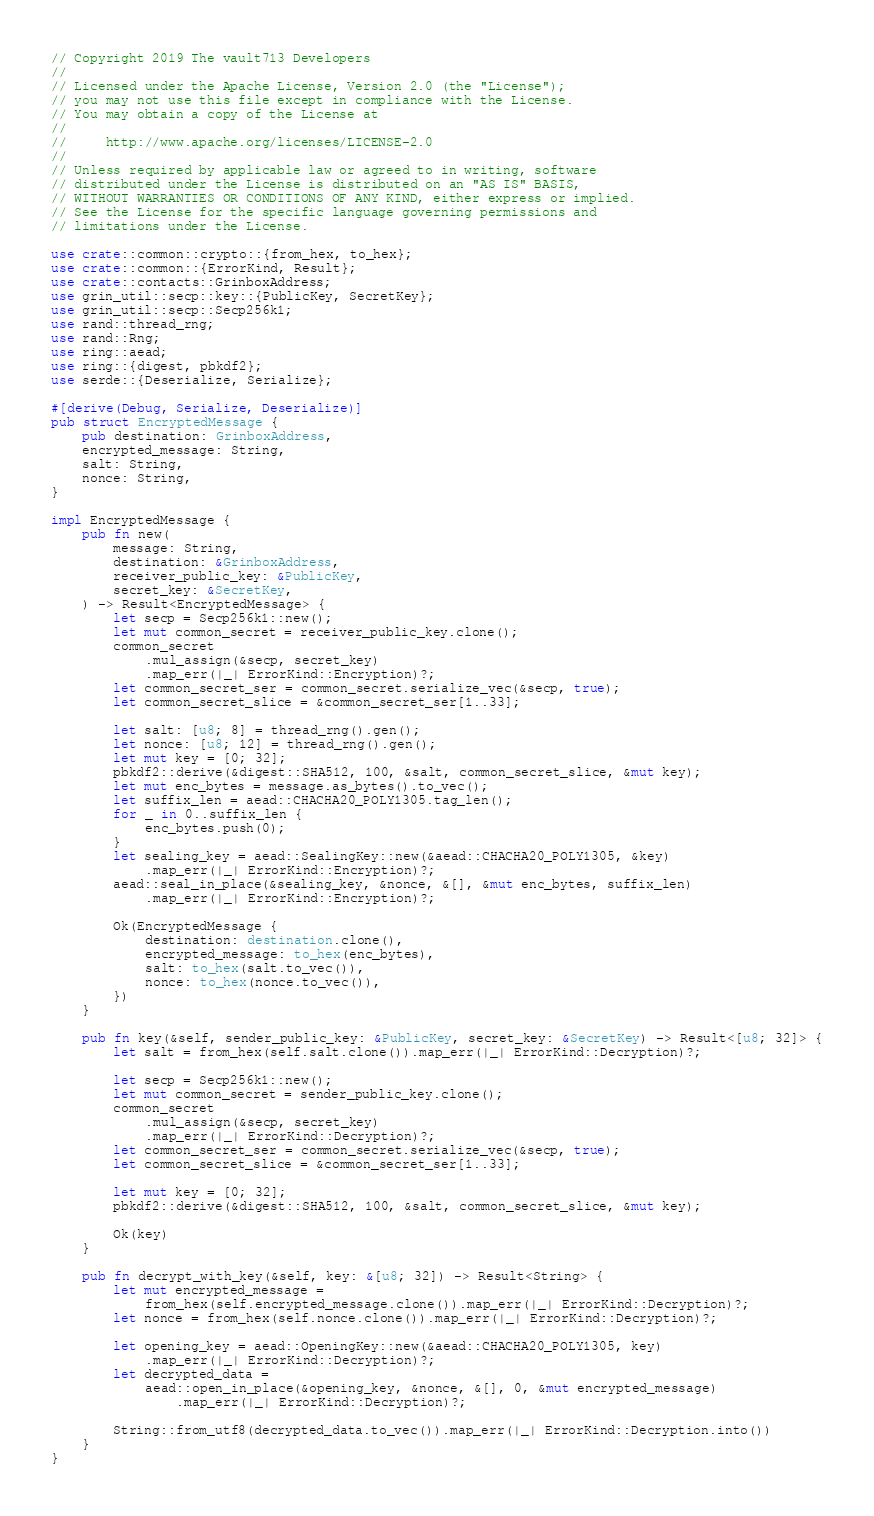<code> <loc_0><loc_0><loc_500><loc_500><_Rust_>// Copyright 2019 The vault713 Developers
//
// Licensed under the Apache License, Version 2.0 (the "License");
// you may not use this file except in compliance with the License.
// You may obtain a copy of the License at
//
//     http://www.apache.org/licenses/LICENSE-2.0
//
// Unless required by applicable law or agreed to in writing, software
// distributed under the License is distributed on an "AS IS" BASIS,
// WITHOUT WARRANTIES OR CONDITIONS OF ANY KIND, either express or implied.
// See the License for the specific language governing permissions and
// limitations under the License.

use crate::common::crypto::{from_hex, to_hex};
use crate::common::{ErrorKind, Result};
use crate::contacts::GrinboxAddress;
use grin_util::secp::key::{PublicKey, SecretKey};
use grin_util::secp::Secp256k1;
use rand::thread_rng;
use rand::Rng;
use ring::aead;
use ring::{digest, pbkdf2};
use serde::{Deserialize, Serialize};

#[derive(Debug, Serialize, Deserialize)]
pub struct EncryptedMessage {
	pub destination: GrinboxAddress,
	encrypted_message: String,
	salt: String,
	nonce: String,
}

impl EncryptedMessage {
	pub fn new(
		message: String,
		destination: &GrinboxAddress,
		receiver_public_key: &PublicKey,
		secret_key: &SecretKey,
	) -> Result<EncryptedMessage> {
		let secp = Secp256k1::new();
		let mut common_secret = receiver_public_key.clone();
		common_secret
			.mul_assign(&secp, secret_key)
			.map_err(|_| ErrorKind::Encryption)?;
		let common_secret_ser = common_secret.serialize_vec(&secp, true);
		let common_secret_slice = &common_secret_ser[1..33];

		let salt: [u8; 8] = thread_rng().gen();
		let nonce: [u8; 12] = thread_rng().gen();
		let mut key = [0; 32];
		pbkdf2::derive(&digest::SHA512, 100, &salt, common_secret_slice, &mut key);
		let mut enc_bytes = message.as_bytes().to_vec();
		let suffix_len = aead::CHACHA20_POLY1305.tag_len();
		for _ in 0..suffix_len {
			enc_bytes.push(0);
		}
		let sealing_key = aead::SealingKey::new(&aead::CHACHA20_POLY1305, &key)
			.map_err(|_| ErrorKind::Encryption)?;
		aead::seal_in_place(&sealing_key, &nonce, &[], &mut enc_bytes, suffix_len)
			.map_err(|_| ErrorKind::Encryption)?;

		Ok(EncryptedMessage {
			destination: destination.clone(),
			encrypted_message: to_hex(enc_bytes),
			salt: to_hex(salt.to_vec()),
			nonce: to_hex(nonce.to_vec()),
		})
	}

	pub fn key(&self, sender_public_key: &PublicKey, secret_key: &SecretKey) -> Result<[u8; 32]> {
		let salt = from_hex(self.salt.clone()).map_err(|_| ErrorKind::Decryption)?;

		let secp = Secp256k1::new();
		let mut common_secret = sender_public_key.clone();
		common_secret
			.mul_assign(&secp, secret_key)
			.map_err(|_| ErrorKind::Decryption)?;
		let common_secret_ser = common_secret.serialize_vec(&secp, true);
		let common_secret_slice = &common_secret_ser[1..33];

		let mut key = [0; 32];
		pbkdf2::derive(&digest::SHA512, 100, &salt, common_secret_slice, &mut key);

		Ok(key)
	}

	pub fn decrypt_with_key(&self, key: &[u8; 32]) -> Result<String> {
		let mut encrypted_message =
			from_hex(self.encrypted_message.clone()).map_err(|_| ErrorKind::Decryption)?;
		let nonce = from_hex(self.nonce.clone()).map_err(|_| ErrorKind::Decryption)?;

		let opening_key = aead::OpeningKey::new(&aead::CHACHA20_POLY1305, key)
			.map_err(|_| ErrorKind::Decryption)?;
		let decrypted_data =
			aead::open_in_place(&opening_key, &nonce, &[], 0, &mut encrypted_message)
				.map_err(|_| ErrorKind::Decryption)?;

		String::from_utf8(decrypted_data.to_vec()).map_err(|_| ErrorKind::Decryption.into())
	}
}
</code> 